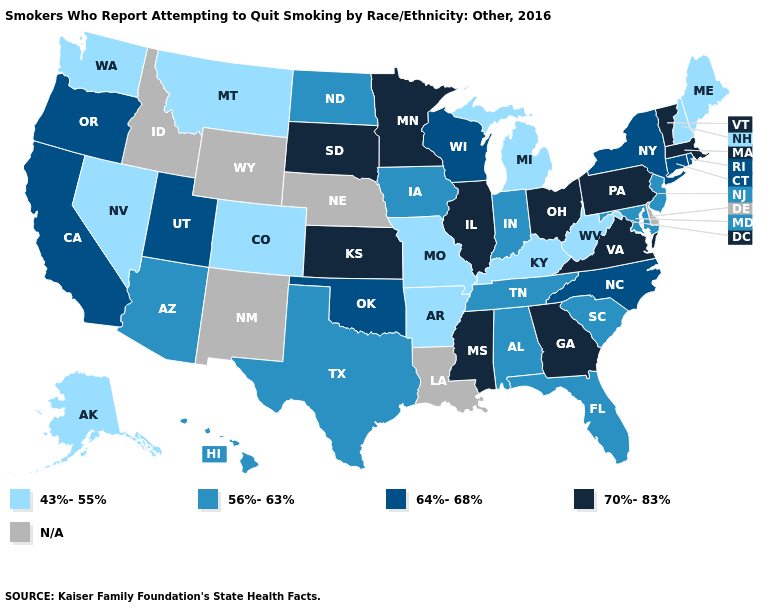What is the value of Oregon?
Be succinct. 64%-68%. What is the value of Alaska?
Concise answer only. 43%-55%. What is the value of Virginia?
Give a very brief answer. 70%-83%. How many symbols are there in the legend?
Write a very short answer. 5. What is the value of Hawaii?
Keep it brief. 56%-63%. Which states have the highest value in the USA?
Concise answer only. Georgia, Illinois, Kansas, Massachusetts, Minnesota, Mississippi, Ohio, Pennsylvania, South Dakota, Vermont, Virginia. Which states hav the highest value in the West?
Short answer required. California, Oregon, Utah. Name the states that have a value in the range 56%-63%?
Give a very brief answer. Alabama, Arizona, Florida, Hawaii, Indiana, Iowa, Maryland, New Jersey, North Dakota, South Carolina, Tennessee, Texas. Name the states that have a value in the range 64%-68%?
Keep it brief. California, Connecticut, New York, North Carolina, Oklahoma, Oregon, Rhode Island, Utah, Wisconsin. Which states hav the highest value in the West?
Short answer required. California, Oregon, Utah. What is the value of Oregon?
Give a very brief answer. 64%-68%. What is the value of Michigan?
Be succinct. 43%-55%. Name the states that have a value in the range N/A?
Keep it brief. Delaware, Idaho, Louisiana, Nebraska, New Mexico, Wyoming. 